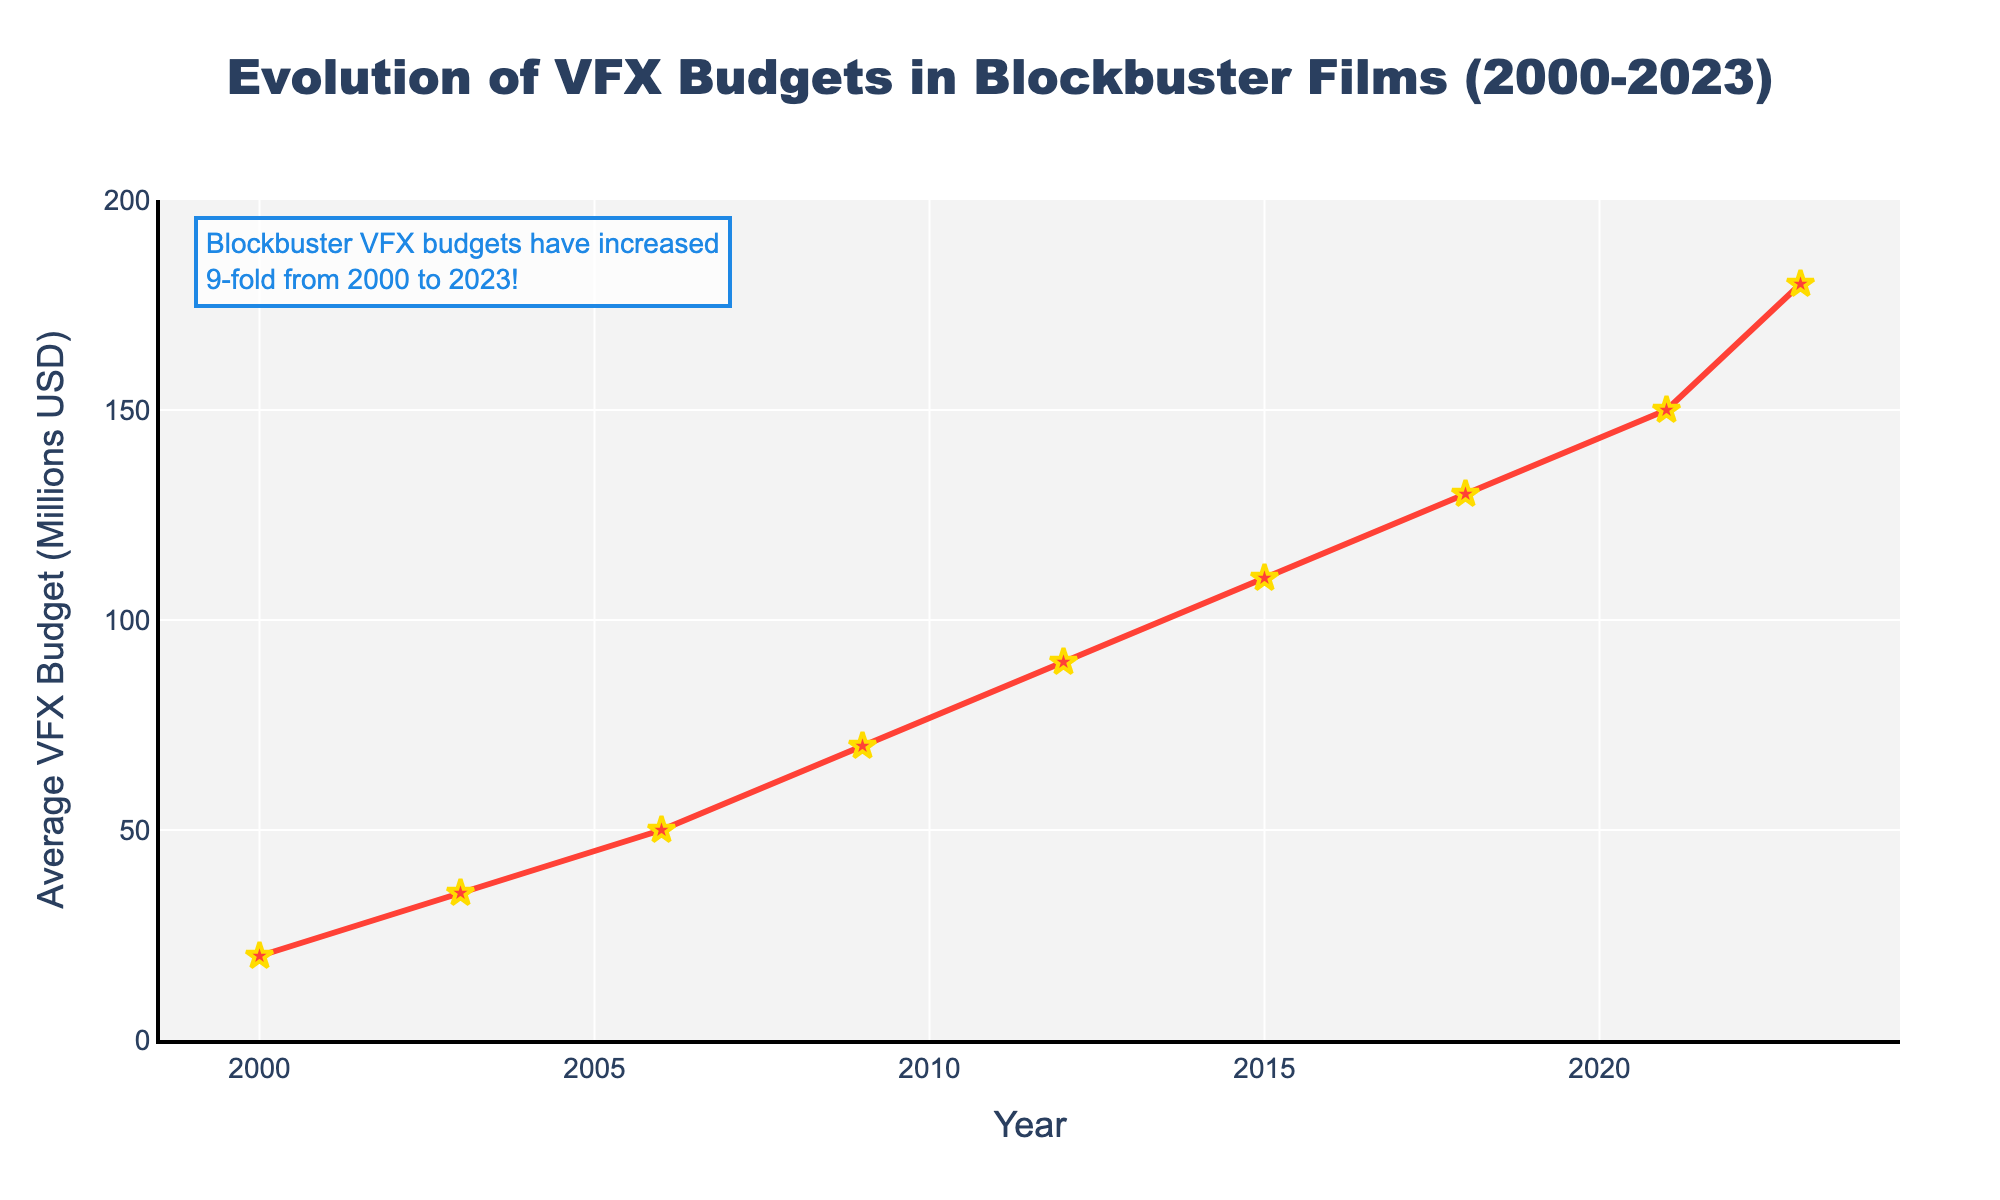What is the average annual increase in VFX budget from 2000 to 2023? Calculate the total increase in VFX budget from 2000 (20 million USD) to 2023 (180 million USD): 180 - 20 = 160. The number of years between 2000 and 2023 is 23. Divide the total increase by the number of years: 160 / 23 ≈ 6.96
Answer: 6.96 million USD/year Between which consecutive years is the largest increase in the average VFX budget observed? Compare the increases between each pair of consecutive years: 2000-2003 (35-20 = 15), 2003-2006 (50-35=15), 2006-2009 (70-50=20), 2009-2012 (90-70=20), 2012-2015 (110-90=20), 2015-2018 (130-110=20), 2018-2021 (150-130=20), 2021-2023 (180-150=30). The largest increase is between 2021 and 2023 (30 million USD).
Answer: 2021-2023 By what percentage did the average VFX budget increase between 2000 and 2023? Calculate the increase in budget from 2000 (20 million USD) to 2023 (180 million USD): 180 - 20 = 160. Then, calculate the percentage increase: (160 / 20) * 100 = 800%
Answer: 800% In which year did the average VFX budget reach 100 million USD? From the chart, we can observe the year when the VFX budget surpasses 100 million USD for the first time. The average VFX budget in 2015 was 110 million USD.
Answer: 2015 How much did the average VFX budget grow from 2009 to 2015? Calculate the budget difference between 2015 (110 million USD) and 2009 (70 million USD): 110 - 70 = 40.
Answer: 40 million USD Which period saw a slower growth rate of VFX budgets, 2000-2009 or 2009-2023? Calculate the growth rates for each period: 2000-2009: (70-20)/(2009-2000) = 50/9 ≈ 5.56 million/year; 2009-2023: (180-70)/(2023-2009) = 110/14 ≈ 7.86 million/year. The period 2000-2009 had the slower growth rate (5.56 million/year).
Answer: 2000-2009 What was the total VFX budget increase from 2003 to 2018? Calculate the budget difference between 2018 (130 million USD) and 2003 (35 million USD): 130 - 35 = 95 million USD.
Answer: 95 million USD How does the average VFX budget in 2018 compare to that in 2003? The VFX budget in 2018 is 130 million USD, and in 2003 it was 35 million USD. Comparing these two, 130 is significantly higher than 35.
Answer: Higher 